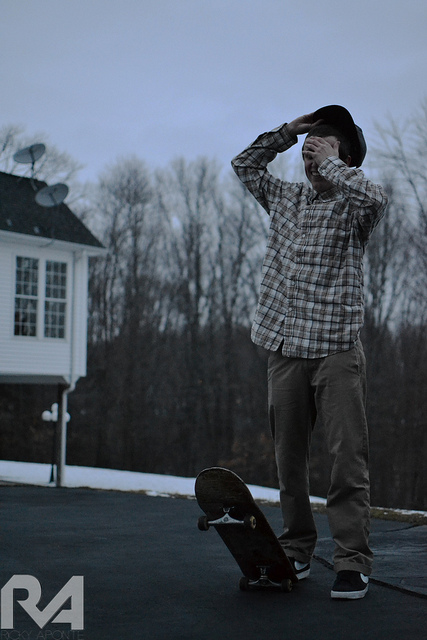<image>What time is it? It is unknown what exact time it is. It could be afternoon, dusk or early evening. What is a possible trick the skateboarder could be performing? I don't know exactly what trick the skateboarder is performing. It could possibly be an ollie or a jump. What is behind the lady? It is ambiguous what is behind the lady. It can be trees, a house, or a man. However, there is also the possibility that there is no lady in the image. What time is it? I don't know the exact time. It can be dusk, 6:00, afternoon, 5:00, early evening or evening. What is a possible trick the skateboarder could be performing? I don't know what trick the skateboarder could be performing. It can be 'ollie', 'jump', 'flipping' or 'skateboarding'. What is behind the lady? I don't know what is behind the lady. It can be man, trees or a house. 